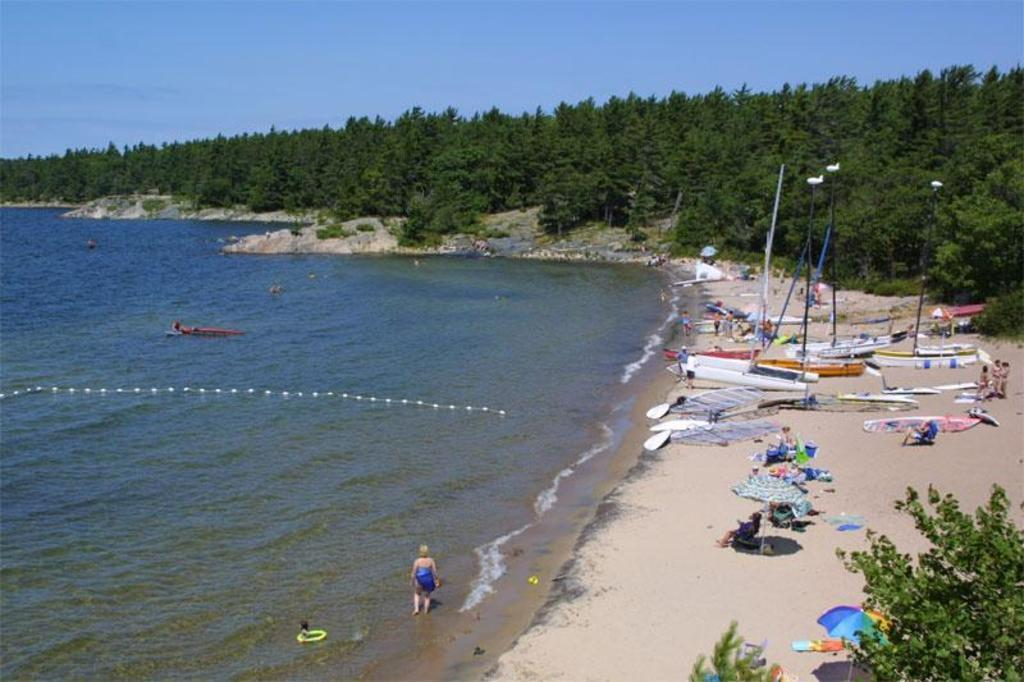What type of natural environment is on the left side of the image? There is a beach on the left side of the image. What are the people on the right side of the image doing? The people are sitting under umbrellas on the right side of the image. What type of vegetation can be seen in the image? There are trees in the image. What is the person in the image doing? A person is standing in the water. What is visible at the top of the image? The sky is visible at the top of the image. What type of collar is the dog wearing on the beach? There is no dog present in the image, and therefore no collar can be observed. How much fuel is needed to power the boat in the image? There is no boat present in the image, so it is not possible to determine the fuel requirements. 